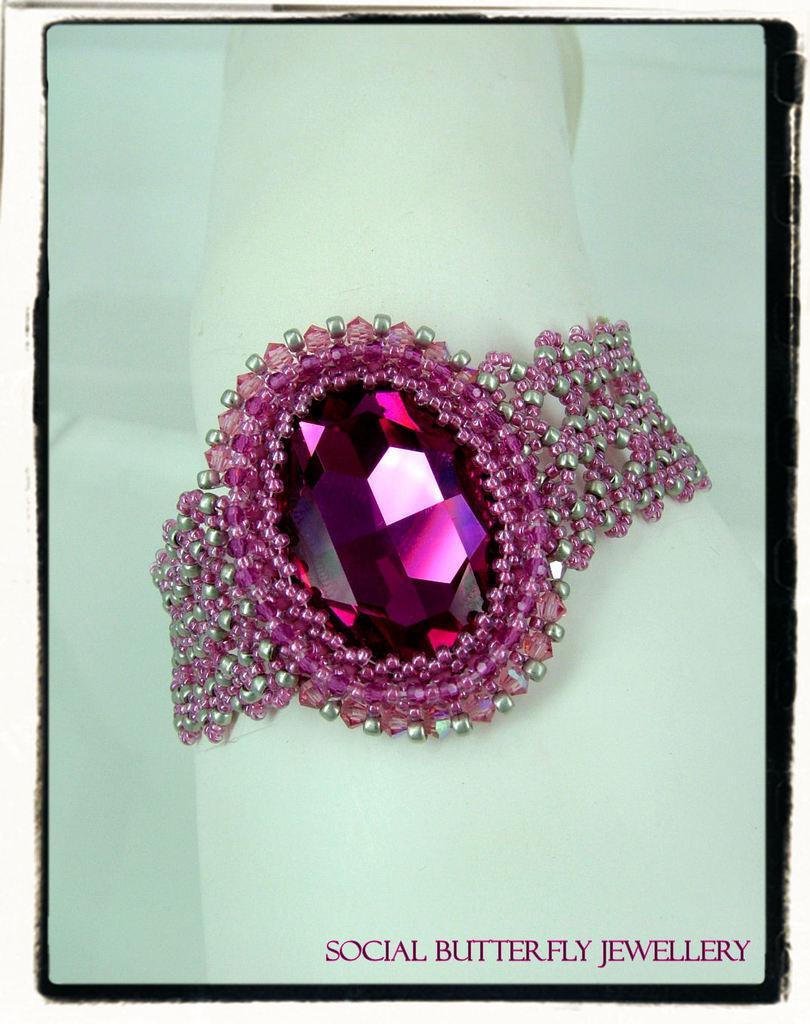Describe this image in one or two sentences. In this picture we can see an ornament, there is a pink color stone in the middle, in the background there is a paper, we can see some text at the bottom. 